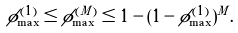Convert formula to latex. <formula><loc_0><loc_0><loc_500><loc_500>\phi ^ { ( 1 ) } _ { \max } \leq \phi ^ { ( M ) } _ { \max } \leq 1 - ( 1 - \phi ^ { ( 1 ) } _ { \max } ) ^ { M } .</formula> 